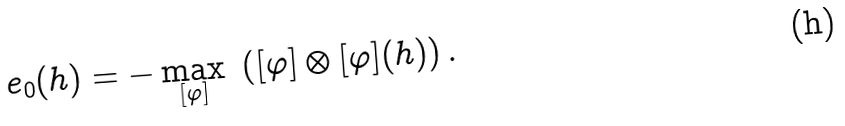<formula> <loc_0><loc_0><loc_500><loc_500>e _ { 0 } ( h ) = - \max _ { [ \varphi ] } \ \left ( [ \varphi ] \otimes [ \varphi ] ( h ) \right ) .</formula> 